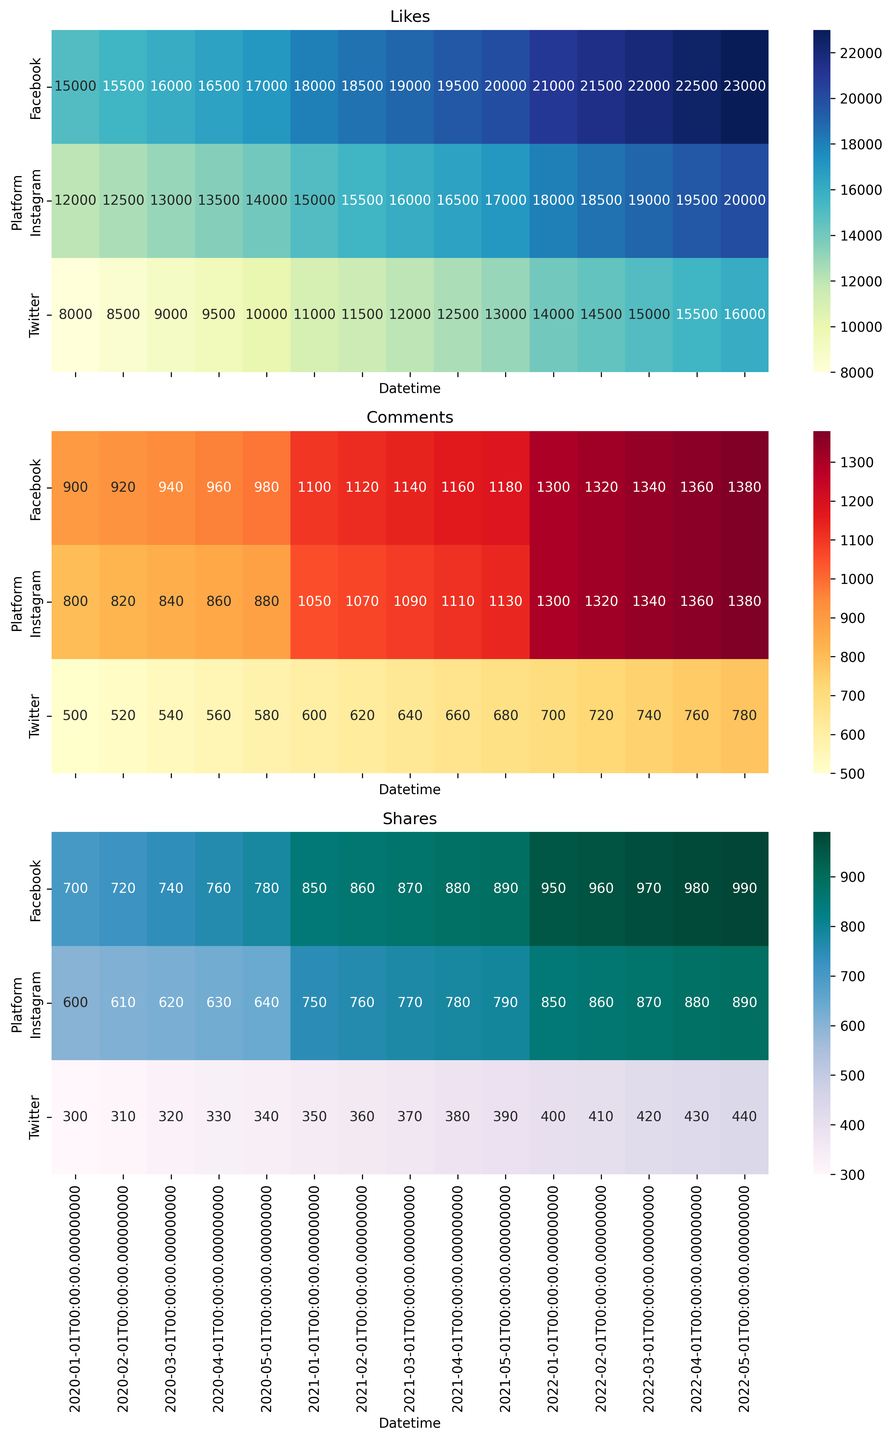What platform had the most likes on January 1, 2022? Look at the heatmap for the 'Likes' section and locate January 1, 2022. The cell with the highest value among Instagram, Twitter, and Facebook represents the most likes.
Answer: Facebook Which month in 2021 did Emma Watson's Instagram receive the most comments? Check the heatmap in the 'Comments' section for 2021. Compare the values for each month and identify the highest value for the Instagram column.
Answer: May In which month did the number of shares on Facebook exceed 900 for the first time? Look at the 'Shares' heatmap and find the first instance after January 2020 where the value in the Facebook row is greater than 900.
Answer: January 2021 Compare the likes on Instagram in January 2021 and May 2022. Which month had fewer likes and by how much? Locate the values in the 'Likes' heatmap for Instagram in January 2021 and May 2022. Subtract the smaller value from the larger to determine the difference.
Answer: January 2021 had 5000 fewer likes What is the average number of comments received by Twitter in 2021? Extract the values from the 'Comments' heatmap for Twitter for all months in 2021, sum them up and then divide by the number of months (5). (600 + 620 + 640 + 660 + 680) / 5 = 640
Answer: 640 Which platform showed the most consistent increase in the number of shares from January 2020 to May 2022? Evaluate the 'Shares' heatmap for all platforms and observe the trendlines. The platform with a steady upward trajectory indicates the most consistent increase.
Answer: Facebook How does the engagement in terms of comments on Twitter in April 2022 compare to that in April 2021? Find the values in the 'Comments' heatmap for Twitter in April 2022 and April 2021. Compare these values to see the difference.
Answer: April 2022 is higher by 100 Which month had the lowest engagement (sum of likes, comments, and shares) on Instagram in 2020? Sum the Likes, Comments, and Shares for each month in 2020 for Instagram and determine the month with the smallest sum.
Answer: January How many more comments did Emma Watson's Facebook posts receive in April 2022 compared to April 2021? Look at the 'Comments' heatmap for April 2022 and April 2021 in Facebook row, then subtract the value of April 2021 from that of April 2022.
Answer: 200 